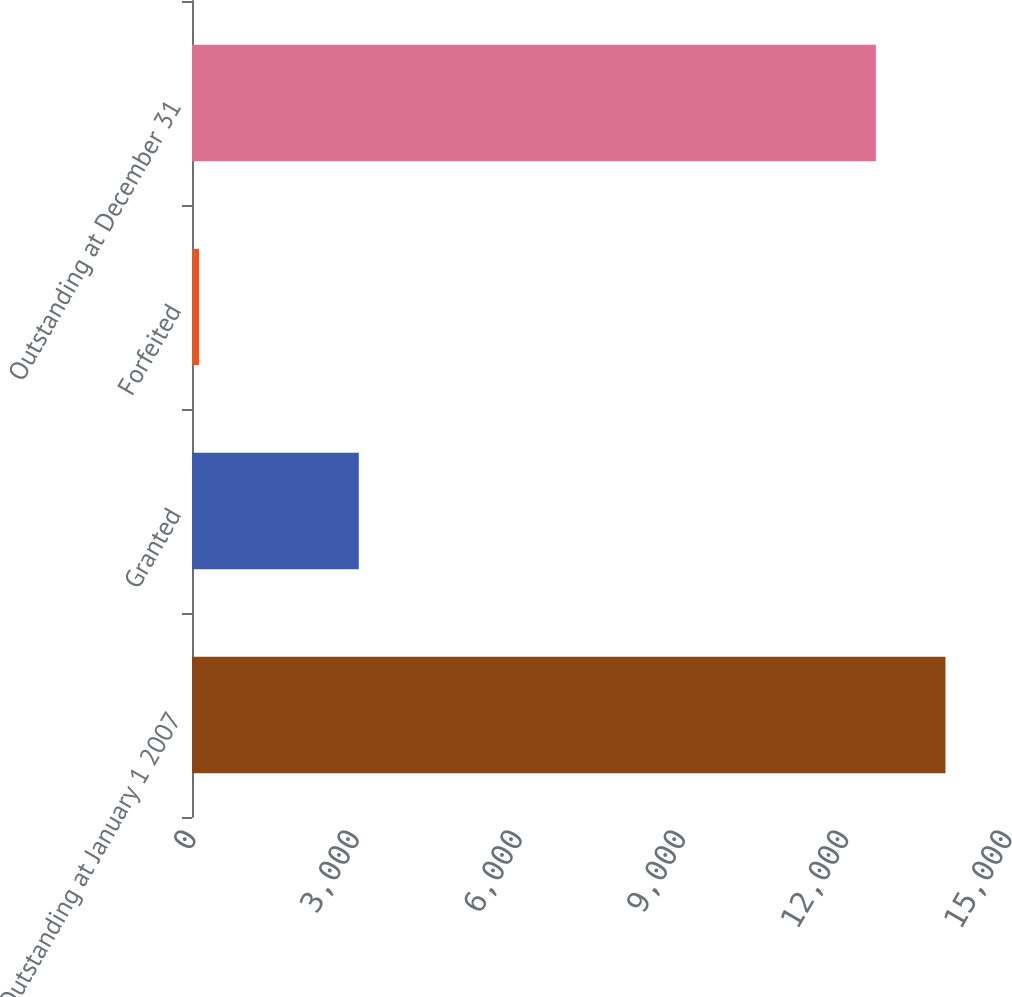<chart> <loc_0><loc_0><loc_500><loc_500><bar_chart><fcel>Outstanding at January 1 2007<fcel>Granted<fcel>Forfeited<fcel>Outstanding at December 31<nl><fcel>13850.4<fcel>3066<fcel>131<fcel>12571.2<nl></chart> 